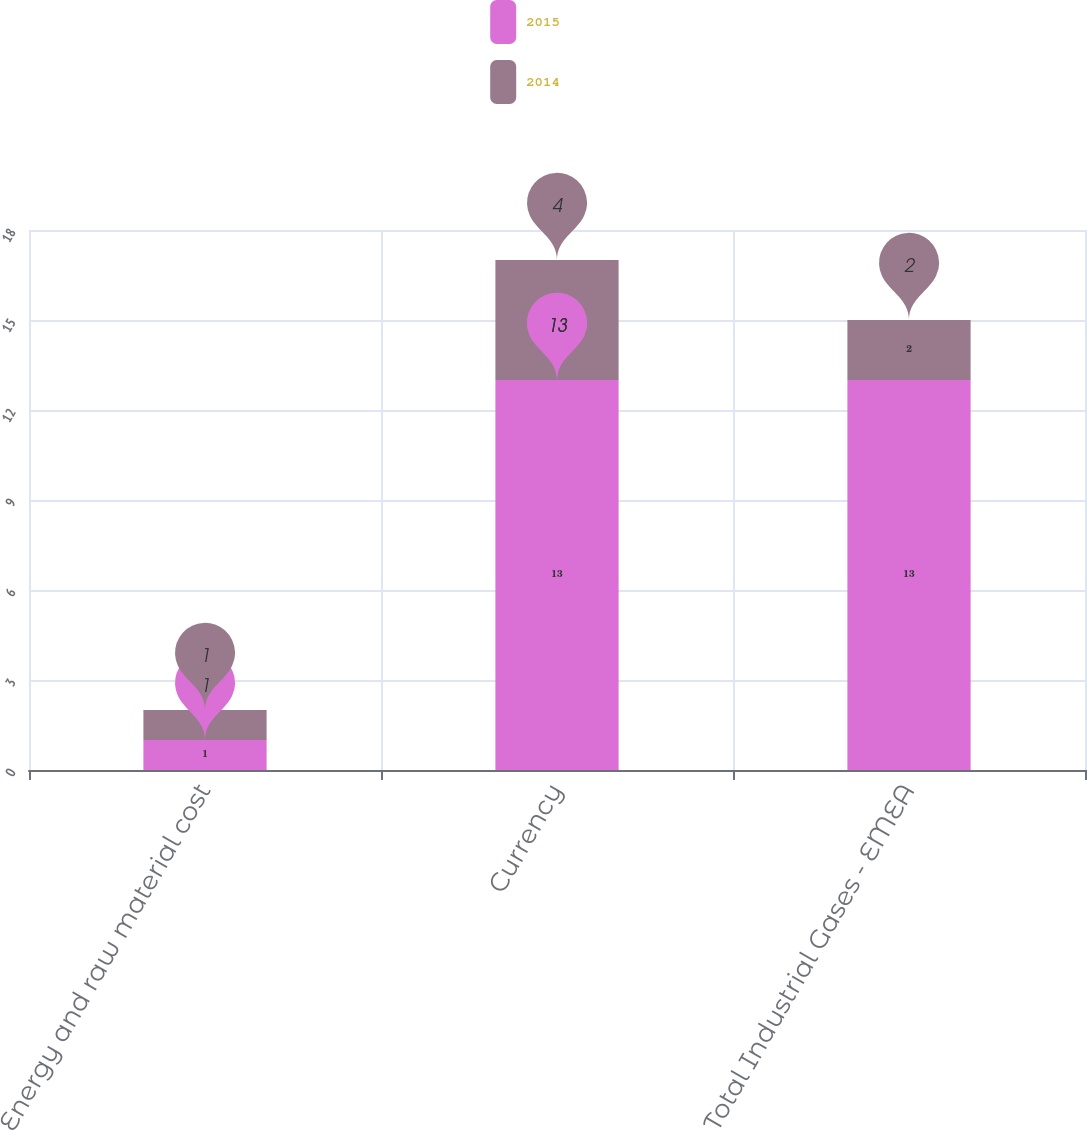<chart> <loc_0><loc_0><loc_500><loc_500><stacked_bar_chart><ecel><fcel>Energy and raw material cost<fcel>Currency<fcel>Total Industrial Gases - EMEA<nl><fcel>2015<fcel>1<fcel>13<fcel>13<nl><fcel>2014<fcel>1<fcel>4<fcel>2<nl></chart> 